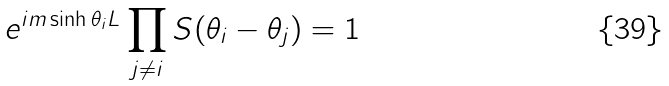<formula> <loc_0><loc_0><loc_500><loc_500>e ^ { i m \sinh \theta _ { i } L } \prod _ { j \ne i } S ( \theta _ { i } - \theta _ { j } ) = 1</formula> 